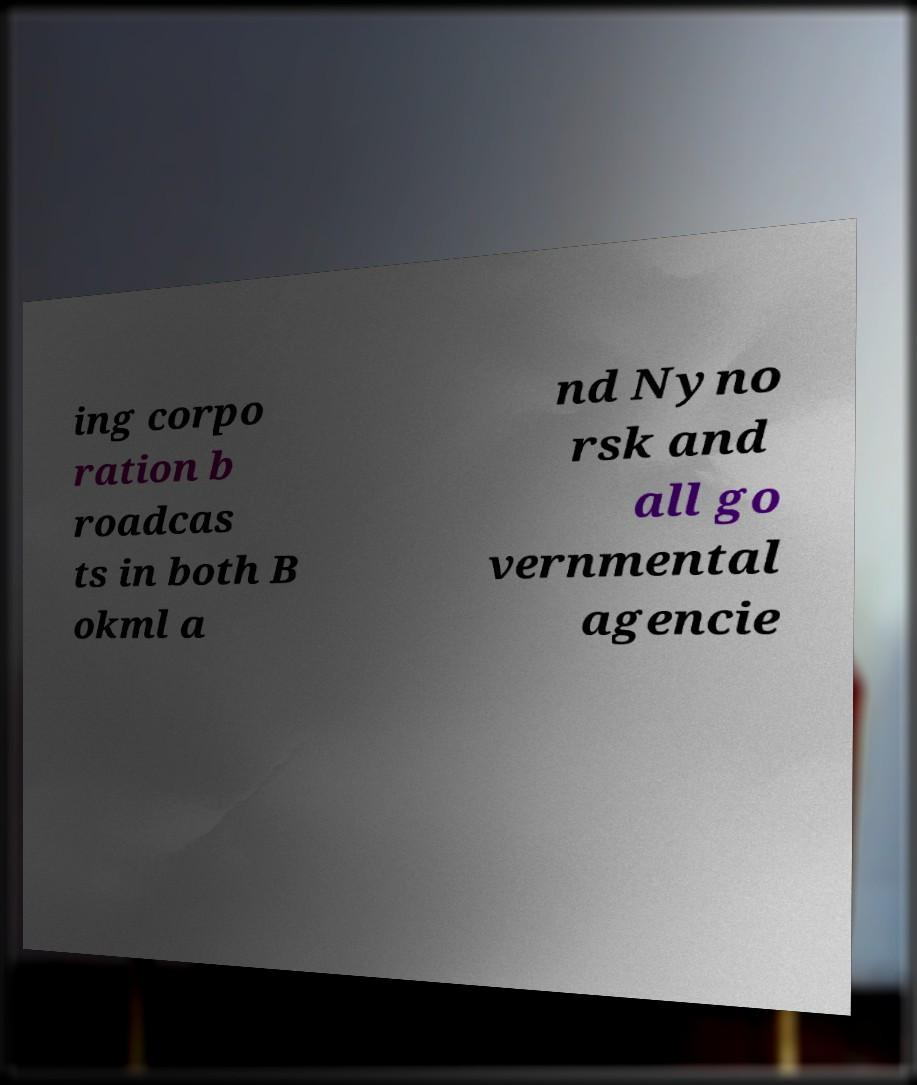Can you read and provide the text displayed in the image?This photo seems to have some interesting text. Can you extract and type it out for me? ing corpo ration b roadcas ts in both B okml a nd Nyno rsk and all go vernmental agencie 